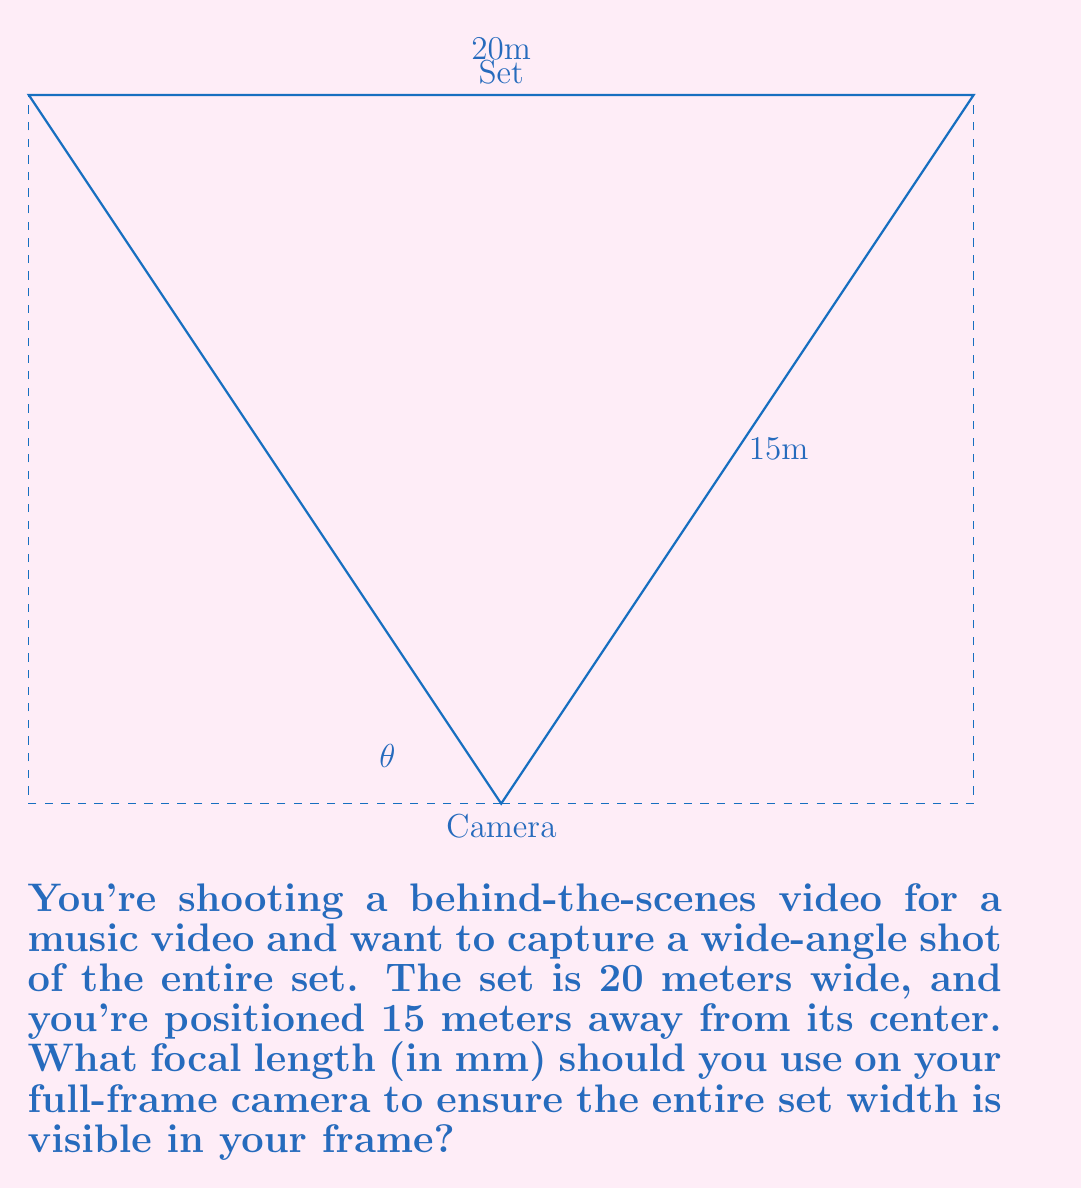Give your solution to this math problem. To solve this problem, we need to follow these steps:

1) First, we need to calculate the angle of view (θ) required to capture the entire set width:

   $$\tan(\frac{\theta}{2}) = \frac{10}{15}$$

   This is because half the set width (10m) forms a right triangle with the distance to the camera (15m).

2) Solving for θ:

   $$\theta = 2 \cdot \arctan(\frac{10}{15}) \approx 67.38°$$

3) Now, we can use the formula relating focal length (f) to the angle of view (θ) for a full-frame camera:

   $$\theta = 2 \cdot \arctan(\frac{36}{2f})$$

   Where 36mm is the width of a full-frame sensor.

4) Substituting our known θ and solving for f:

   $$67.38° = 2 \cdot \arctan(\frac{36}{2f})$$
   $$\tan(33.69°) = \frac{18}{f}$$
   $$f = \frac{18}{\tan(33.69°)} \approx 26.8 \text{ mm}$$

Therefore, you should use a focal length of approximately 26.8 mm to capture the entire set width in your frame.
Answer: 26.8 mm 